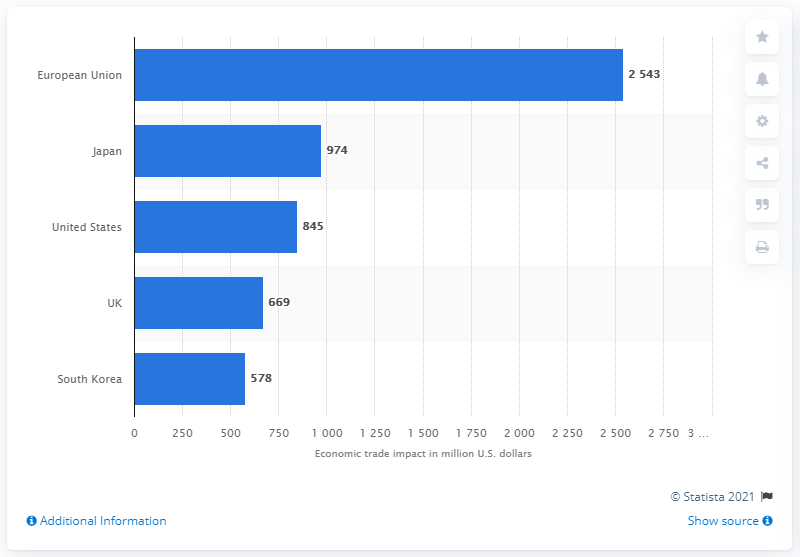Outline some significant characteristics in this image. The European Union is the country with the highest economic trade impact in terms of million US dollars. The economic trade impact between Japan and the UK is expected to differ by approximately 305 million US dollars. 